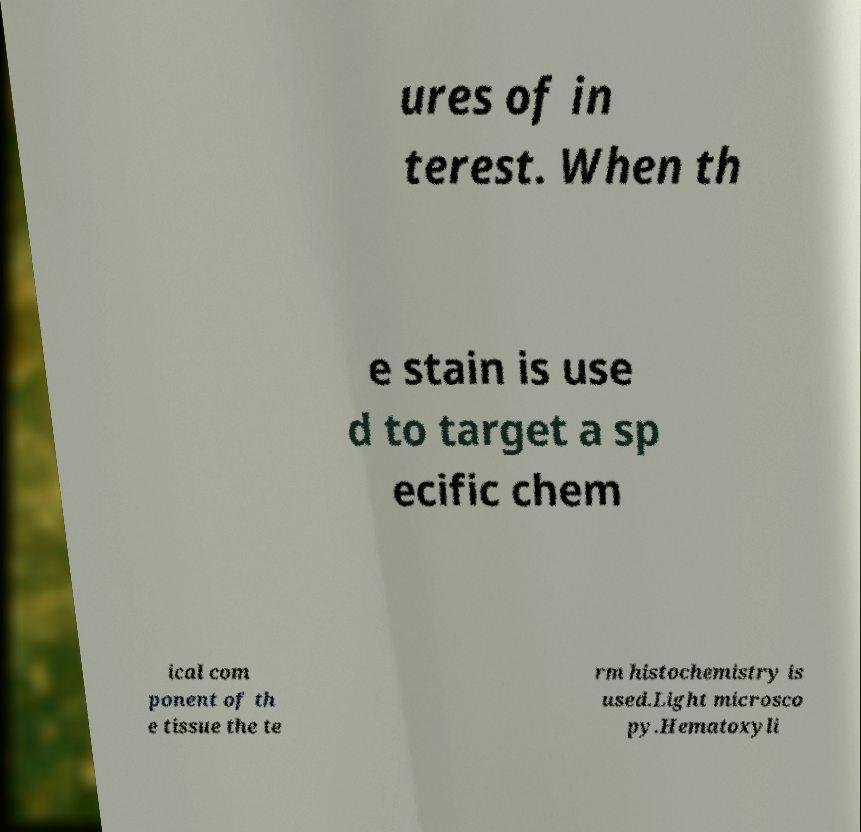I need the written content from this picture converted into text. Can you do that? ures of in terest. When th e stain is use d to target a sp ecific chem ical com ponent of th e tissue the te rm histochemistry is used.Light microsco py.Hematoxyli 